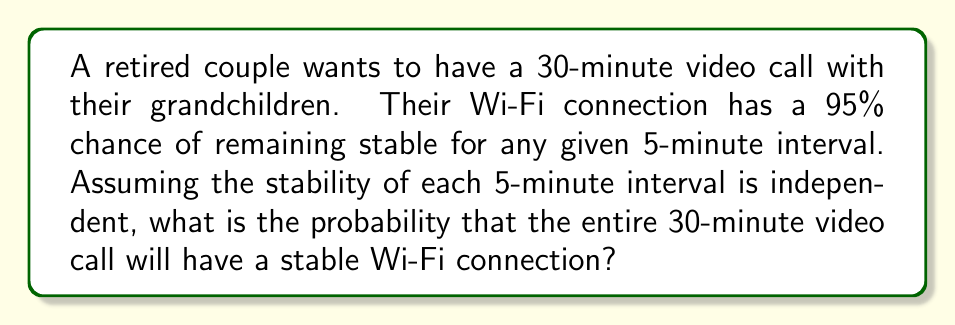Provide a solution to this math problem. Let's approach this step-by-step:

1) First, we need to determine how many 5-minute intervals are in a 30-minute call:
   $\frac{30 \text{ minutes}}{5 \text{ minutes per interval}} = 6 \text{ intervals}$

2) The probability of a stable connection for one 5-minute interval is 95% or 0.95.

3) We need all 6 intervals to be stable for the entire call to be stable. This is equivalent to the probability of 6 independent events all occurring.

4) When we have independent events and we want all of them to occur, we multiply their individual probabilities:

   $P(\text{all stable}) = 0.95 \times 0.95 \times 0.95 \times 0.95 \times 0.95 \times 0.95$

5) This can be written as an exponent:

   $P(\text{all stable}) = 0.95^6$

6) Now we can calculate this:

   $P(\text{all stable}) = 0.95^6 \approx 0.7351$

7) To convert to a percentage, we multiply by 100:

   $0.7351 \times 100 \approx 73.51\%$
Answer: $73.51\%$ 